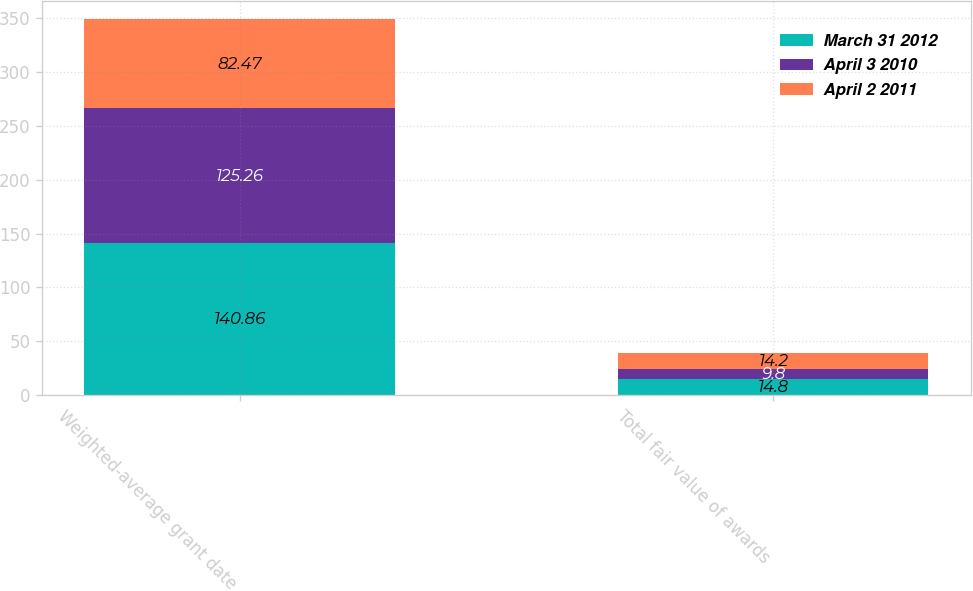Convert chart to OTSL. <chart><loc_0><loc_0><loc_500><loc_500><stacked_bar_chart><ecel><fcel>Weighted-average grant date<fcel>Total fair value of awards<nl><fcel>March 31 2012<fcel>140.86<fcel>14.8<nl><fcel>April 3 2010<fcel>125.26<fcel>9.8<nl><fcel>April 2 2011<fcel>82.47<fcel>14.2<nl></chart> 